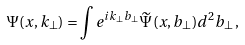Convert formula to latex. <formula><loc_0><loc_0><loc_500><loc_500>\Psi ( x , k _ { \perp } ) = \int e ^ { i k _ { \perp } b _ { \perp } } \widetilde { \Psi } ( x , b _ { \perp } ) d ^ { 2 } b _ { \perp } \, ,</formula> 